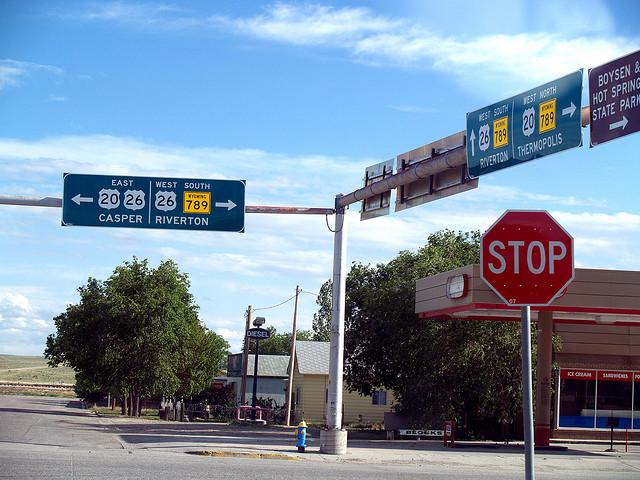What building does the diesel sign most likely foreshadow?

Choices:
A) grocery store
B) school
C) gas station
D) train station gas station 